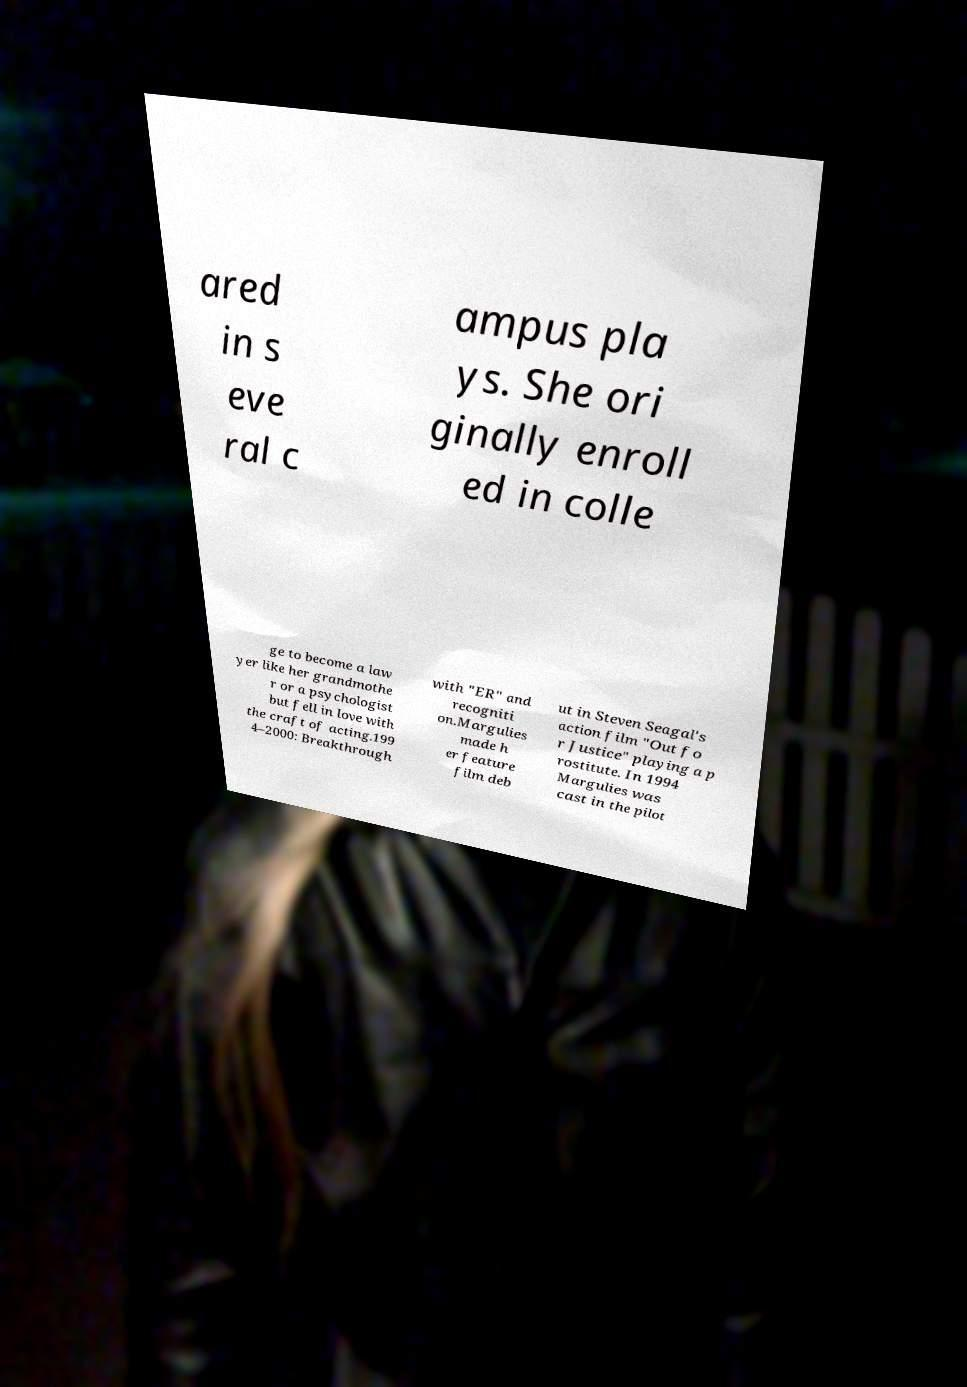Please read and relay the text visible in this image. What does it say? ared in s eve ral c ampus pla ys. She ori ginally enroll ed in colle ge to become a law yer like her grandmothe r or a psychologist but fell in love with the craft of acting.199 4–2000: Breakthrough with "ER" and recogniti on.Margulies made h er feature film deb ut in Steven Seagal's action film "Out fo r Justice" playing a p rostitute. In 1994 Margulies was cast in the pilot 